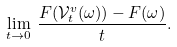Convert formula to latex. <formula><loc_0><loc_0><loc_500><loc_500>\lim _ { t \to 0 } \, \frac { F ( { \mathcal { V } } _ { t } ^ { v } ( \omega ) ) - F ( \omega ) } { t } .</formula> 